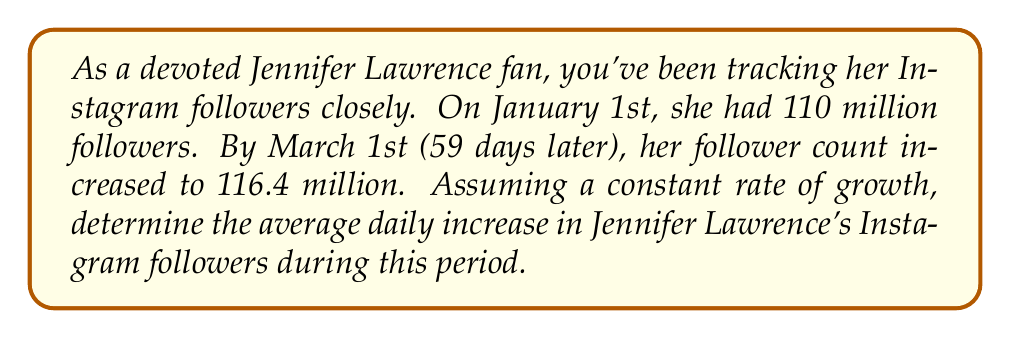Teach me how to tackle this problem. To solve this problem, we need to calculate the rate of change in followers over time. Let's break it down step-by-step:

1. Identify the given information:
   - Initial followers (January 1st): 110 million
   - Final followers (March 1st): 116.4 million
   - Time period: 59 days

2. Calculate the total increase in followers:
   $\text{Increase} = \text{Final followers} - \text{Initial followers}$
   $\text{Increase} = 116.4 \text{ million} - 110 \text{ million} = 6.4 \text{ million}$

3. Use the rate of change formula:
   $$\text{Rate of change} = \frac{\text{Change in quantity}}{\text{Change in time}}$$

4. Plug in the values:
   $$\text{Rate of change} = \frac{6.4 \text{ million followers}}{59 \text{ days}}$$

5. Perform the division:
   $$\text{Rate of change} = \frac{6,400,000}{59} \approx 108,474.58 \text{ followers per day}$$

Therefore, Jennifer Lawrence gained an average of approximately 108,475 followers per day during this period.
Answer: The average daily increase in Jennifer Lawrence's Instagram followers was approximately 108,475 followers per day. 